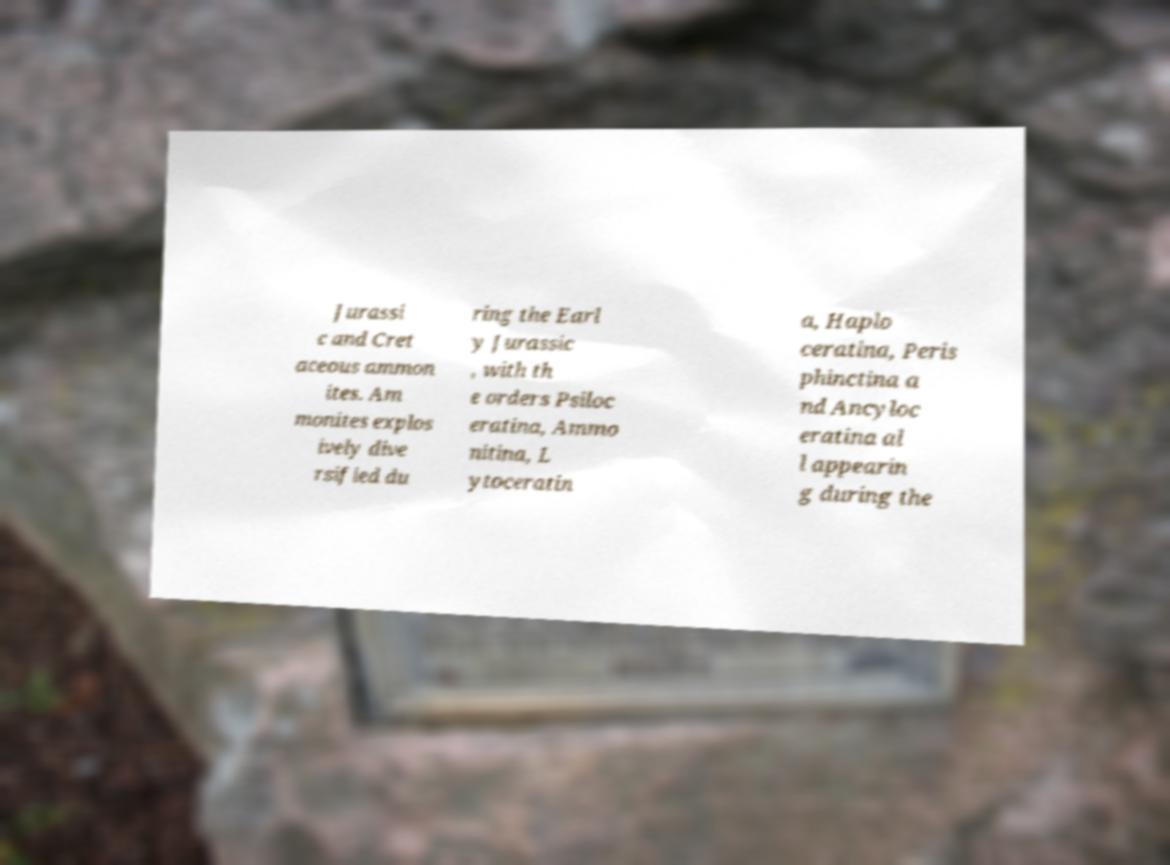Could you extract and type out the text from this image? Jurassi c and Cret aceous ammon ites. Am monites explos ively dive rsified du ring the Earl y Jurassic , with th e orders Psiloc eratina, Ammo nitina, L ytoceratin a, Haplo ceratina, Peris phinctina a nd Ancyloc eratina al l appearin g during the 